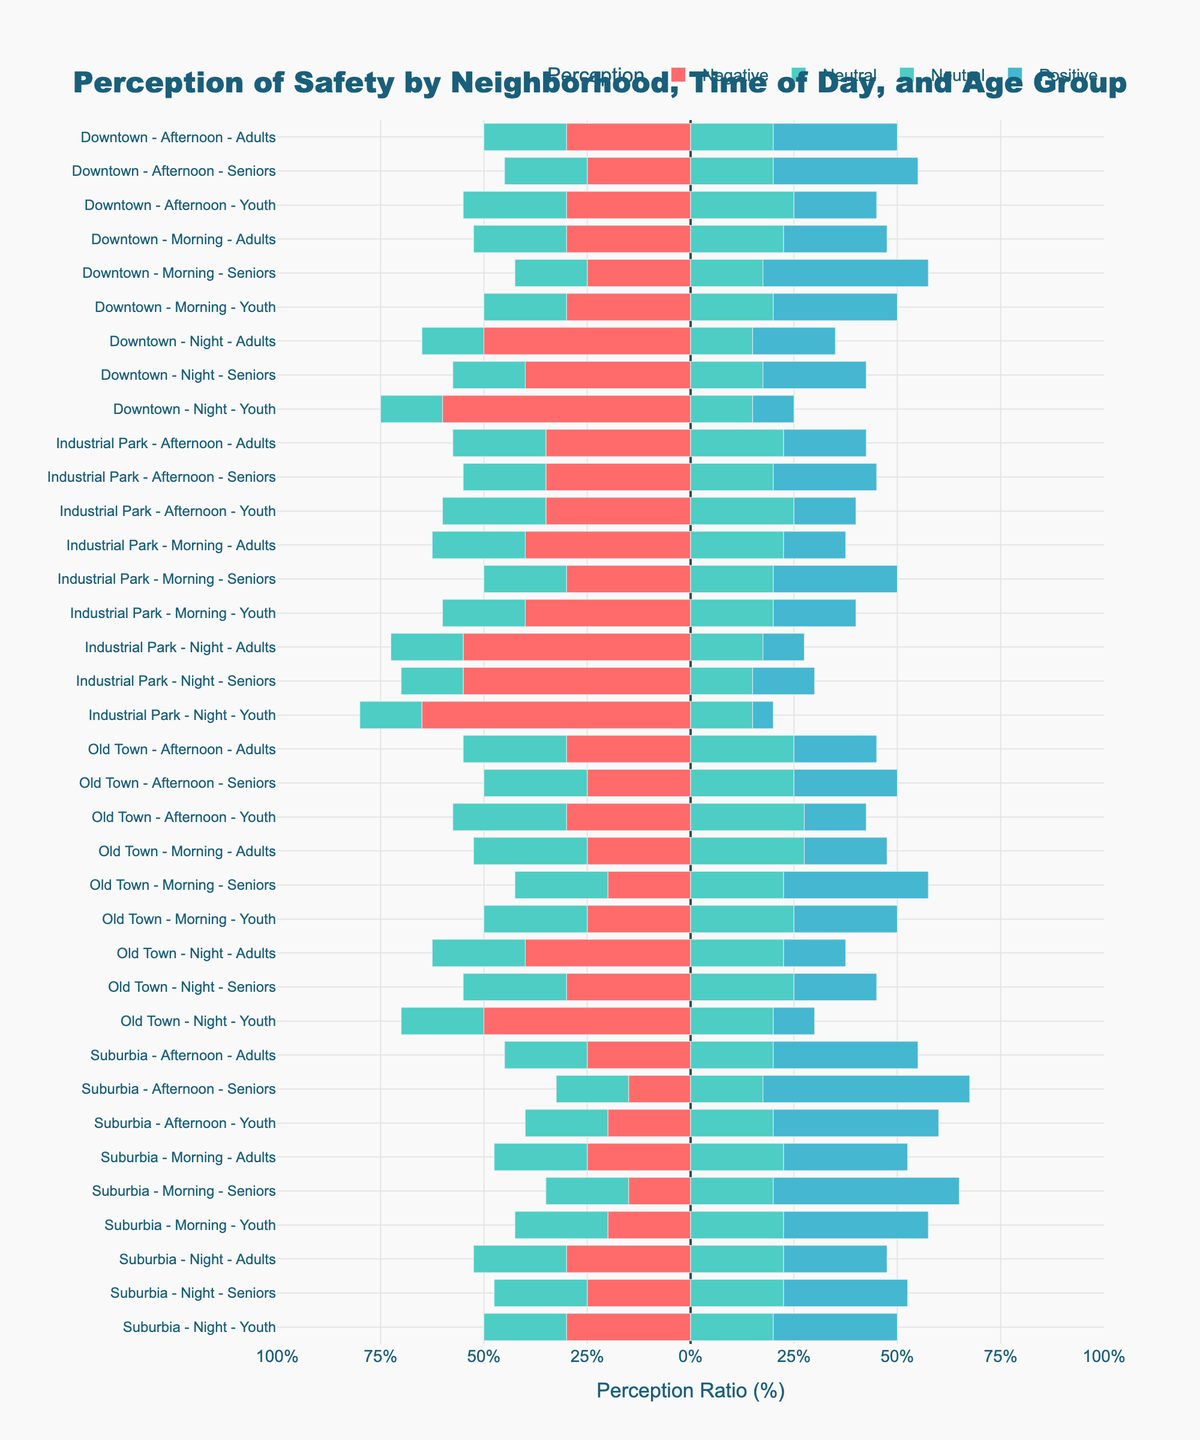What's the overall trend in the perception of safety during nighttime for all age groups in Downtown? To answer this, look at the bars corresponding to 'Downtown - Night' for 'Youth', 'Adults', and 'Seniors'. Each bar shows predominant negative perceptions (long red segments) with lesser positive and neutral perceptions. This indicates that at night, the safety perception is largely negative across all age groups in Downtown.
Answer: Predominantly negative In Old Town, which age group has the highest positive perception in the morning? Look at the bars corresponding to 'Old Town - Morning' and compare the lengths of the blue segments (positive perception) for 'Youth', 'Adults', and 'Seniors'. The senior group has the longest blue bar.
Answer: Seniors Compare the difference in positive perception between Youth during the afternoon in Downtown and Suburbia. Look at the 'Downtown - Afternoon - Youth' and 'Suburbia - Afternoon - Youth' blue segments. Downtown shows 20% positive perception while Suburbia shows 40%. The difference is 40% - 20%.
Answer: 20% Is there a neighborhood where the positive perception of safety at night is higher than negative perception for any age group? Examine the bars representing nighttime for each neighborhood and check if the blue segment (positive perception) is longer than the red segment (negative perception). No bar has a longer blue segment compared to the red at night.
Answer: No In the Industrial Park, which time of day shows the highest neutral perception for adults? Look at the 'Industrial Park' bars for 'Adults'. Compare the lengths of the green segments during Morning, Afternoon, and Night. The afternoon has the longest green segment.
Answer: Afternoon Calculate the net perception of safety (positive perception - negative perception) for Suburbia, Adults, Morning based on the figure. 'Suburbia - Morning - Adults' bar shows approximately 30% positive and 25% negative perception. The net perception is 30% - 25%.
Answer: 5% Compare negative perceptions of safety between Youth and Seniors in Old Town at night. Which is higher? Look at 'Old Town - Night - Youth' and 'Old Town - Night - Seniors' red segments. The youth negative perception is at 50%, while seniors are at 30%.
Answer: Youth In Downtown, which age group feels the least safe in the morning? Compare the red segments (negative perception) for 'Downtown - Morning' for Youth, Adults, and Seniors. The length of the red segment is equal across Youth and Adults at 30%, while Seniors have 25%. Youth and Adults feel the least safe.
Answer: Youth and Adults What is the combined neutral perception ratio for Youth during the afternoon in all neighborhoods? Find and sum the green segments' (neutral perception) lengths for 'Afternoon - Youth' in 'Downtown', 'Suburbia', 'Old Town', and 'Industrial Park'. Values are 50%, 40%, 55%, and 50% respectively. Summing these gives 50% + 40% + 55% + 50% = 195%.
Answer: 195% Which age group perceives the Industrial Park as the least safe at night? Look at 'Industrial Park - Night' bars for 'Youth', 'Adults', and 'Seniors'. The group with the longest red segment (negative perception) perceives it as the least safe. For all groups, the red segment is quite substantial, but youth has the longest negative segment at 65%.
Answer: Youth 